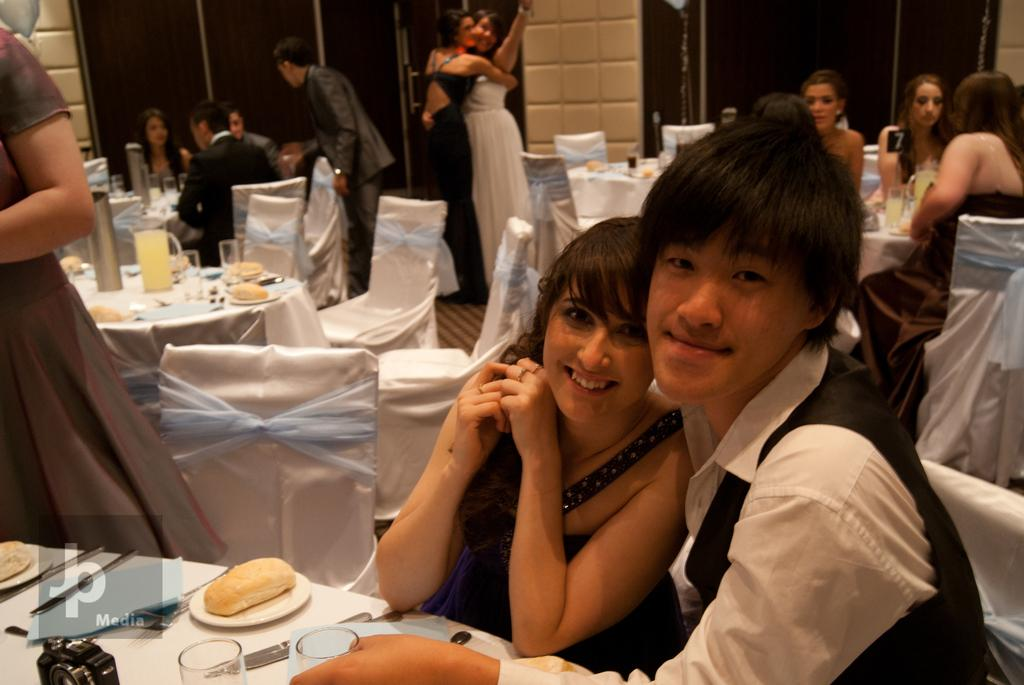What are the people in the room doing? The people in the room are sitting on chairs. What is on the table in the room? There is a jug, glasses, food items, spoons, forks, knives, and a camera on the table. What type of utensils are present on the table? There are spoons, forks, and knives on the table. What type of creature is captured in the image taken by the camera on the table? There is no creature captured in the image taken by the camera on the table, as the camera's contents are not visible in the image. What is the answer to the question about the voyage in the image? There is no mention of a voyage in the image, so there is no answer to that question. 